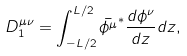<formula> <loc_0><loc_0><loc_500><loc_500>D _ { 1 } ^ { \mu \nu } = \int _ { - L / 2 } ^ { L / 2 } \bar { \phi ^ { \mu } } ^ { * } \frac { d \phi ^ { \nu } } { d z } d z ,</formula> 